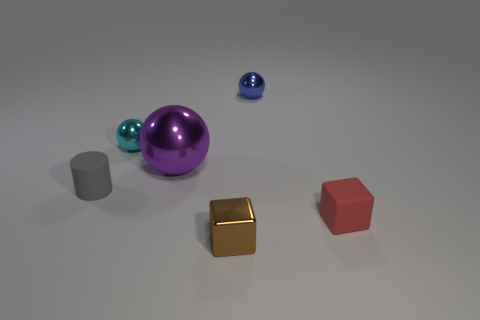Add 1 small blue metallic things. How many objects exist? 7 Subtract all cubes. How many objects are left? 4 Add 3 yellow shiny things. How many yellow shiny things exist? 3 Subtract 0 blue cylinders. How many objects are left? 6 Subtract all red rubber things. Subtract all cyan things. How many objects are left? 4 Add 3 small cyan metal objects. How many small cyan metal objects are left? 4 